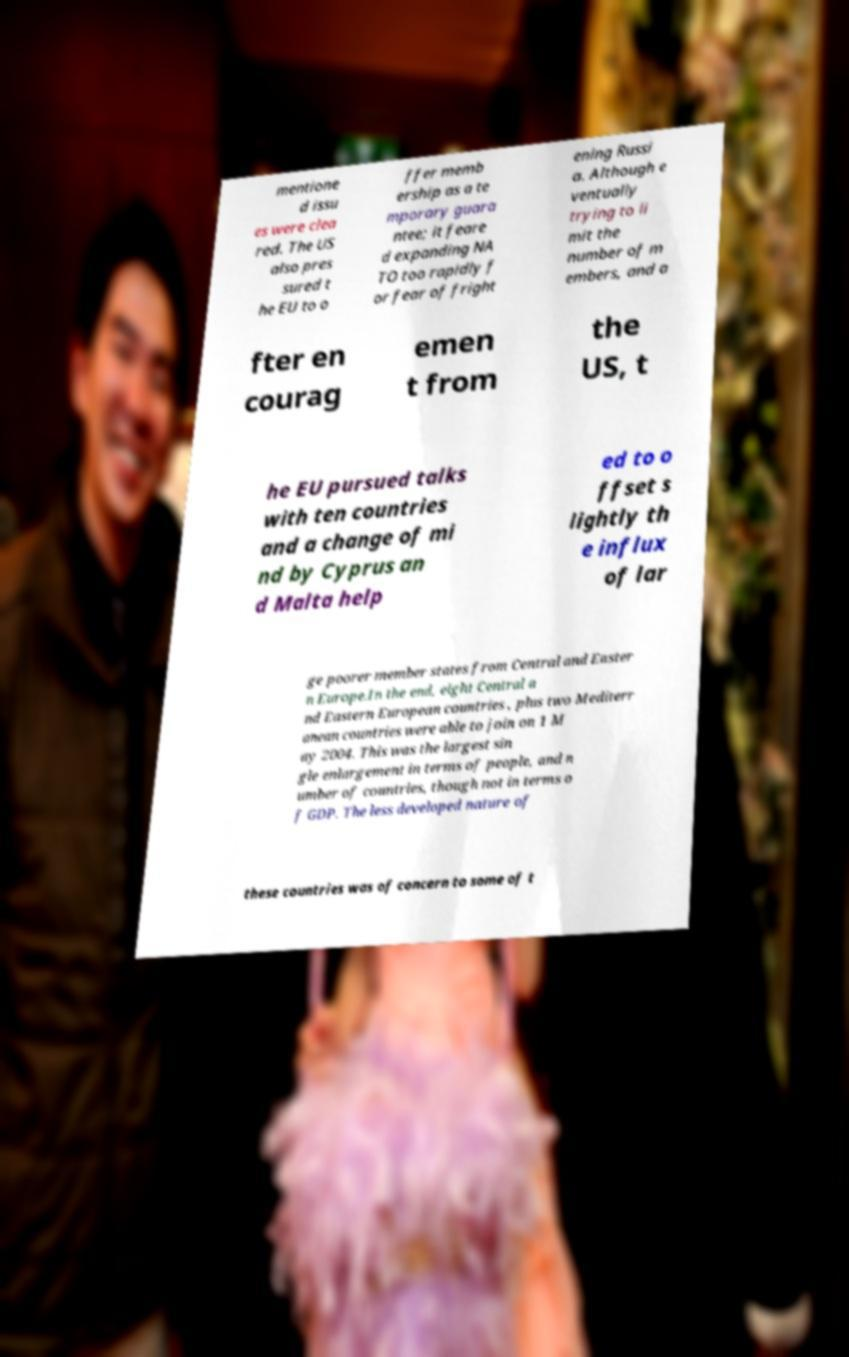Please read and relay the text visible in this image. What does it say? mentione d issu es were clea red. The US also pres sured t he EU to o ffer memb ership as a te mporary guara ntee; it feare d expanding NA TO too rapidly f or fear of fright ening Russi a. Although e ventually trying to li mit the number of m embers, and a fter en courag emen t from the US, t he EU pursued talks with ten countries and a change of mi nd by Cyprus an d Malta help ed to o ffset s lightly th e influx of lar ge poorer member states from Central and Easter n Europe.In the end, eight Central a nd Eastern European countries , plus two Mediterr anean countries were able to join on 1 M ay 2004. This was the largest sin gle enlargement in terms of people, and n umber of countries, though not in terms o f GDP. The less developed nature of these countries was of concern to some of t 